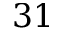<formula> <loc_0><loc_0><loc_500><loc_500>3 1</formula> 